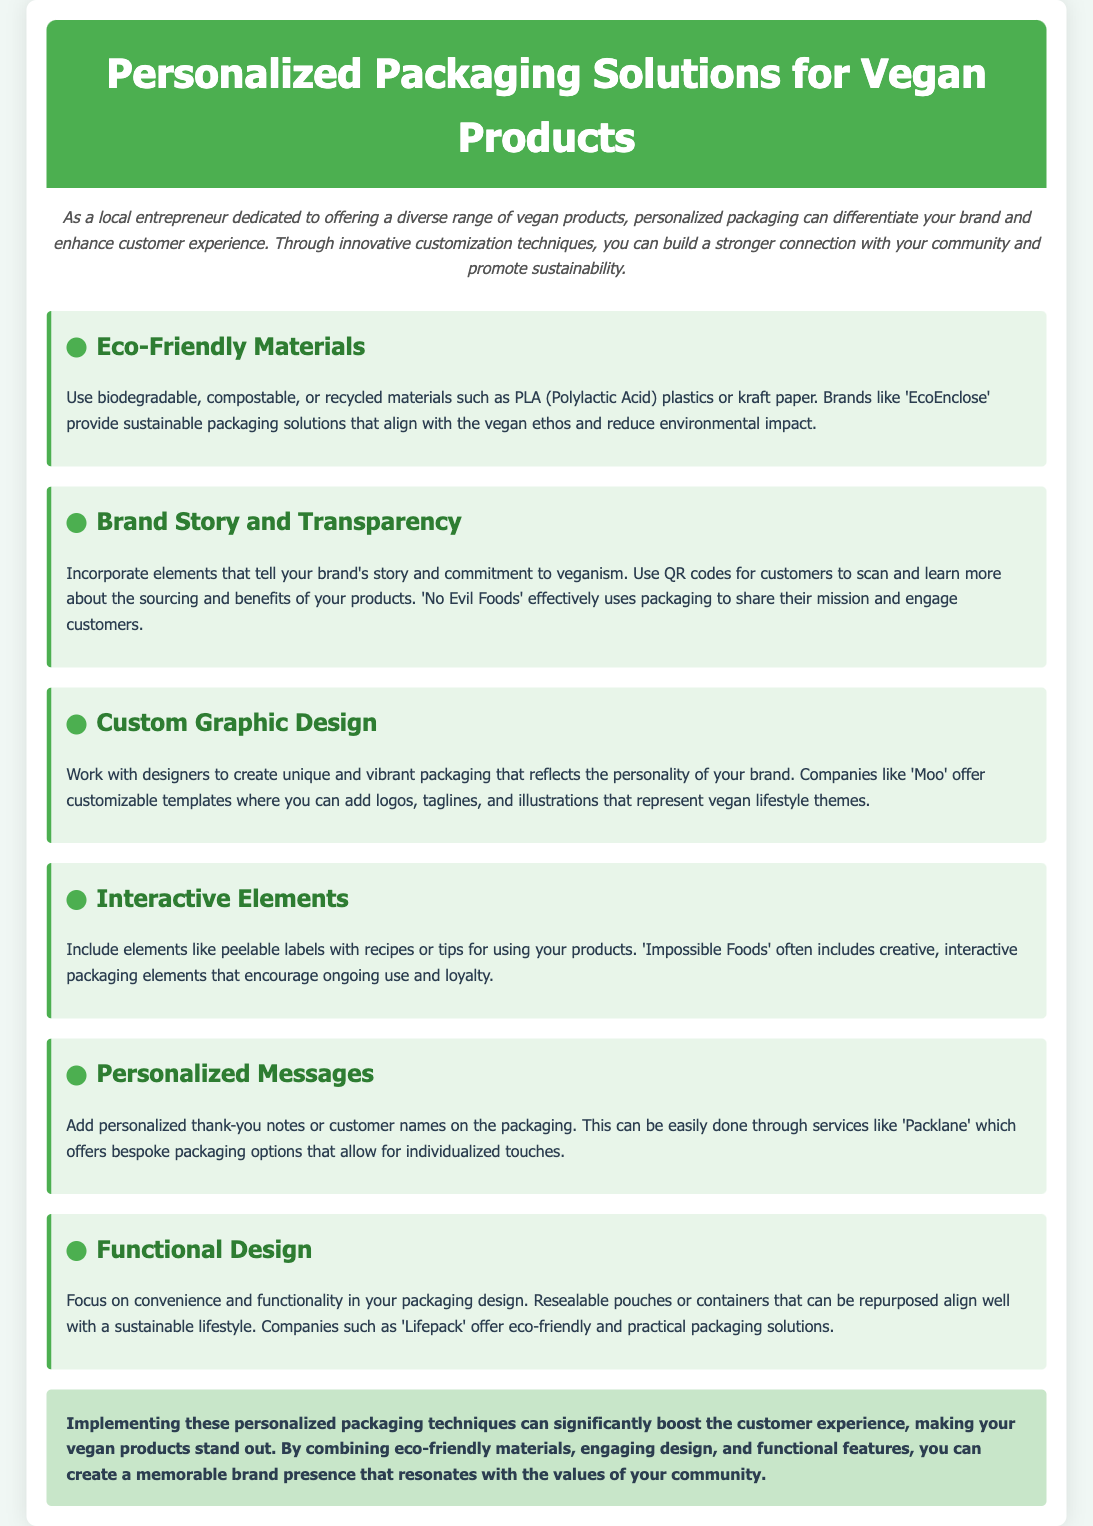What are eco-friendly materials suggested for packaging? The document mentions biodegradable, compostable, or recycled materials such as PLA plastics or kraft paper.
Answer: PLA plastics or kraft paper What company provides sustainable packaging solutions? The document refers to 'EcoEnclose' as a brand offering sustainable packaging solutions.
Answer: EcoEnclose What interactive element is mentioned that could be included on packaging? The document states that peelable labels with recipes or tips are suggested as an interactive element.
Answer: Peelable labels What personalized touch can be added to the packaging? The document indicates that personalized thank-you notes or customer names can enhance the packaging.
Answer: Thank-you notes Which company is mentioned for providing bespoke packaging options? The document highlights 'Packlane' as a service for bespoke packaging options.
Answer: Packlane What is the benefit of using custom graphic design according to the document? The document asserts that custom graphic design helps reflect the personality of the brand.
Answer: Reflect personality What packaging design focus is suggested for convenience? The document emphasizes focusing on convenience and functionality in packaging design.
Answer: Convenience and functionality What is a benefit of using eco-friendly materials in vegan packaging? The document states that eco-friendly materials align with the vegan ethos and reduce environmental impact.
Answer: Reduce environmental impact What feature do resealable pouches provide? The document notes that resealable pouches offer convenience and can be repurposed.
Answer: Convenience and repurposing 